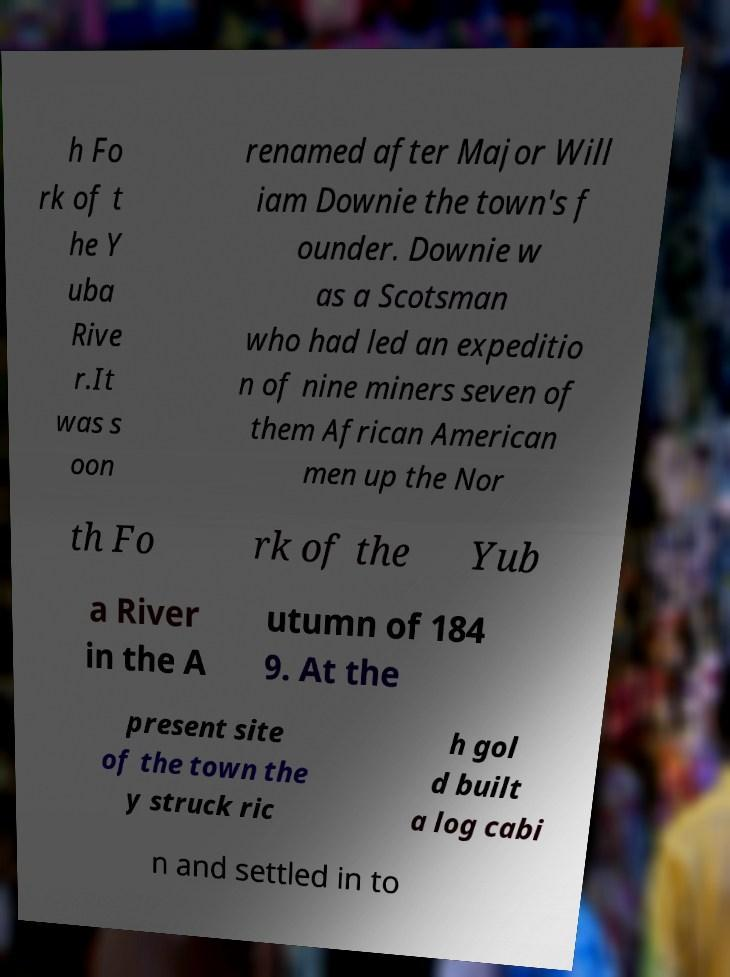Can you accurately transcribe the text from the provided image for me? h Fo rk of t he Y uba Rive r.It was s oon renamed after Major Will iam Downie the town's f ounder. Downie w as a Scotsman who had led an expeditio n of nine miners seven of them African American men up the Nor th Fo rk of the Yub a River in the A utumn of 184 9. At the present site of the town the y struck ric h gol d built a log cabi n and settled in to 